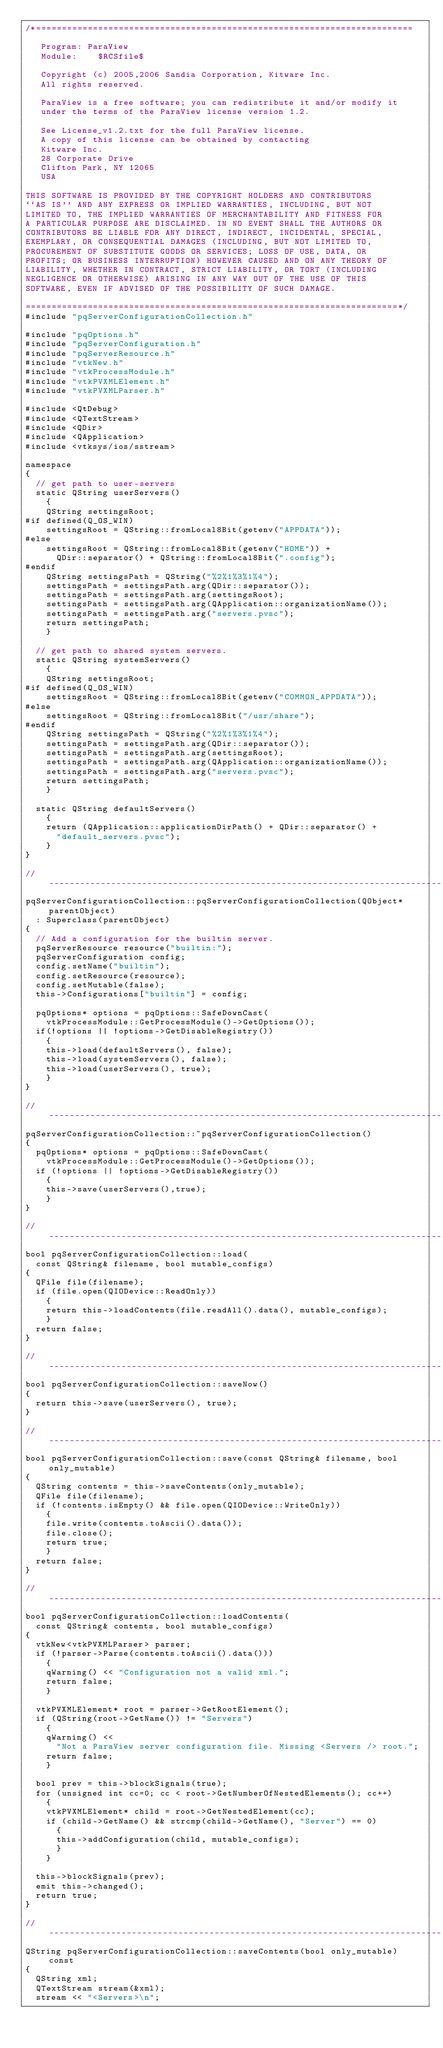Convert code to text. <code><loc_0><loc_0><loc_500><loc_500><_C++_>/*=========================================================================

   Program: ParaView
   Module:    $RCSfile$

   Copyright (c) 2005,2006 Sandia Corporation, Kitware Inc.
   All rights reserved.

   ParaView is a free software; you can redistribute it and/or modify it
   under the terms of the ParaView license version 1.2. 

   See License_v1.2.txt for the full ParaView license.
   A copy of this license can be obtained by contacting
   Kitware Inc.
   28 Corporate Drive
   Clifton Park, NY 12065
   USA

THIS SOFTWARE IS PROVIDED BY THE COPYRIGHT HOLDERS AND CONTRIBUTORS
``AS IS'' AND ANY EXPRESS OR IMPLIED WARRANTIES, INCLUDING, BUT NOT
LIMITED TO, THE IMPLIED WARRANTIES OF MERCHANTABILITY AND FITNESS FOR
A PARTICULAR PURPOSE ARE DISCLAIMED. IN NO EVENT SHALL THE AUTHORS OR
CONTRIBUTORS BE LIABLE FOR ANY DIRECT, INDIRECT, INCIDENTAL, SPECIAL,
EXEMPLARY, OR CONSEQUENTIAL DAMAGES (INCLUDING, BUT NOT LIMITED TO,
PROCUREMENT OF SUBSTITUTE GOODS OR SERVICES; LOSS OF USE, DATA, OR
PROFITS; OR BUSINESS INTERRUPTION) HOWEVER CAUSED AND ON ANY THEORY OF
LIABILITY, WHETHER IN CONTRACT, STRICT LIABILITY, OR TORT (INCLUDING
NEGLIGENCE OR OTHERWISE) ARISING IN ANY WAY OUT OF THE USE OF THIS
SOFTWARE, EVEN IF ADVISED OF THE POSSIBILITY OF SUCH DAMAGE.

========================================================================*/
#include "pqServerConfigurationCollection.h"

#include "pqOptions.h"
#include "pqServerConfiguration.h"
#include "pqServerResource.h"
#include "vtkNew.h"
#include "vtkProcessModule.h"
#include "vtkPVXMLElement.h"
#include "vtkPVXMLParser.h"

#include <QtDebug>
#include <QTextStream>
#include <QDir>
#include <QApplication>
#include <vtksys/ios/sstream>

namespace
{
  // get path to user-servers
  static QString userServers()
    {
    QString settingsRoot;
#if defined(Q_OS_WIN)
    settingsRoot = QString::fromLocal8Bit(getenv("APPDATA"));
#else
    settingsRoot = QString::fromLocal8Bit(getenv("HOME")) +
      QDir::separator() + QString::fromLocal8Bit(".config");
#endif
    QString settingsPath = QString("%2%1%3%1%4");
    settingsPath = settingsPath.arg(QDir::separator());
    settingsPath = settingsPath.arg(settingsRoot);
    settingsPath = settingsPath.arg(QApplication::organizationName());
    settingsPath = settingsPath.arg("servers.pvsc");
    return settingsPath;
    }

  // get path to shared system servers.
  static QString systemServers()
    {
    QString settingsRoot;
#if defined(Q_OS_WIN)
    settingsRoot = QString::fromLocal8Bit(getenv("COMMON_APPDATA"));
#else
    settingsRoot = QString::fromLocal8Bit("/usr/share");
#endif
    QString settingsPath = QString("%2%1%3%1%4");
    settingsPath = settingsPath.arg(QDir::separator());
    settingsPath = settingsPath.arg(settingsRoot);
    settingsPath = settingsPath.arg(QApplication::organizationName());
    settingsPath = settingsPath.arg("servers.pvsc");
    return settingsPath;
    }

  static QString defaultServers()
    {
    return (QApplication::applicationDirPath() + QDir::separator() +
      "default_servers.pvsc");
    }
}

//-----------------------------------------------------------------------------
pqServerConfigurationCollection::pqServerConfigurationCollection(QObject* parentObject)
  : Superclass(parentObject)
{
  // Add a configuration for the builtin server.
  pqServerResource resource("builtin:");
  pqServerConfiguration config;
  config.setName("builtin");
  config.setResource(resource);
  config.setMutable(false);
  this->Configurations["builtin"] = config;

  pqOptions* options = pqOptions::SafeDownCast(
    vtkProcessModule::GetProcessModule()->GetOptions());
  if(!options || !options->GetDisableRegistry())
    {
    this->load(defaultServers(), false);
    this->load(systemServers(), false);
    this->load(userServers(), true);
    }
}

//-----------------------------------------------------------------------------
pqServerConfigurationCollection::~pqServerConfigurationCollection()
{
  pqOptions* options = pqOptions::SafeDownCast(
    vtkProcessModule::GetProcessModule()->GetOptions());
  if (!options || !options->GetDisableRegistry())
    {
    this->save(userServers(),true);
    }
}

//-----------------------------------------------------------------------------
bool pqServerConfigurationCollection::load(
  const QString& filename, bool mutable_configs)
{
  QFile file(filename);
  if (file.open(QIODevice::ReadOnly))
    {
    return this->loadContents(file.readAll().data(), mutable_configs);
    }
  return false;
}

//-----------------------------------------------------------------------------
bool pqServerConfigurationCollection::saveNow()
{
  return this->save(userServers(), true);
}

//-----------------------------------------------------------------------------
bool pqServerConfigurationCollection::save(const QString& filename, bool only_mutable)
{
  QString contents = this->saveContents(only_mutable);
  QFile file(filename);
  if (!contents.isEmpty() && file.open(QIODevice::WriteOnly))
    {
    file.write(contents.toAscii().data());
    file.close();
    return true;
    }
  return false;
}

//-----------------------------------------------------------------------------
bool pqServerConfigurationCollection::loadContents(
  const QString& contents, bool mutable_configs)
{
  vtkNew<vtkPVXMLParser> parser;
  if (!parser->Parse(contents.toAscii().data()))
    {
    qWarning() << "Configuration not a valid xml.";
    return false;
    }

  vtkPVXMLElement* root = parser->GetRootElement();
  if (QString(root->GetName()) != "Servers")
    {
    qWarning() << 
      "Not a ParaView server configuration file. Missing <Servers /> root.";
    return false;
    }

  bool prev = this->blockSignals(true);
  for (unsigned int cc=0; cc < root->GetNumberOfNestedElements(); cc++)
    {
    vtkPVXMLElement* child = root->GetNestedElement(cc);
    if (child->GetName() && strcmp(child->GetName(), "Server") == 0)
      {
      this->addConfiguration(child, mutable_configs);
      }
    }

  this->blockSignals(prev);
  emit this->changed();
  return true;
}

//-----------------------------------------------------------------------------
QString pqServerConfigurationCollection::saveContents(bool only_mutable) const
{
  QString xml;
  QTextStream stream(&xml);
  stream << "<Servers>\n";</code> 